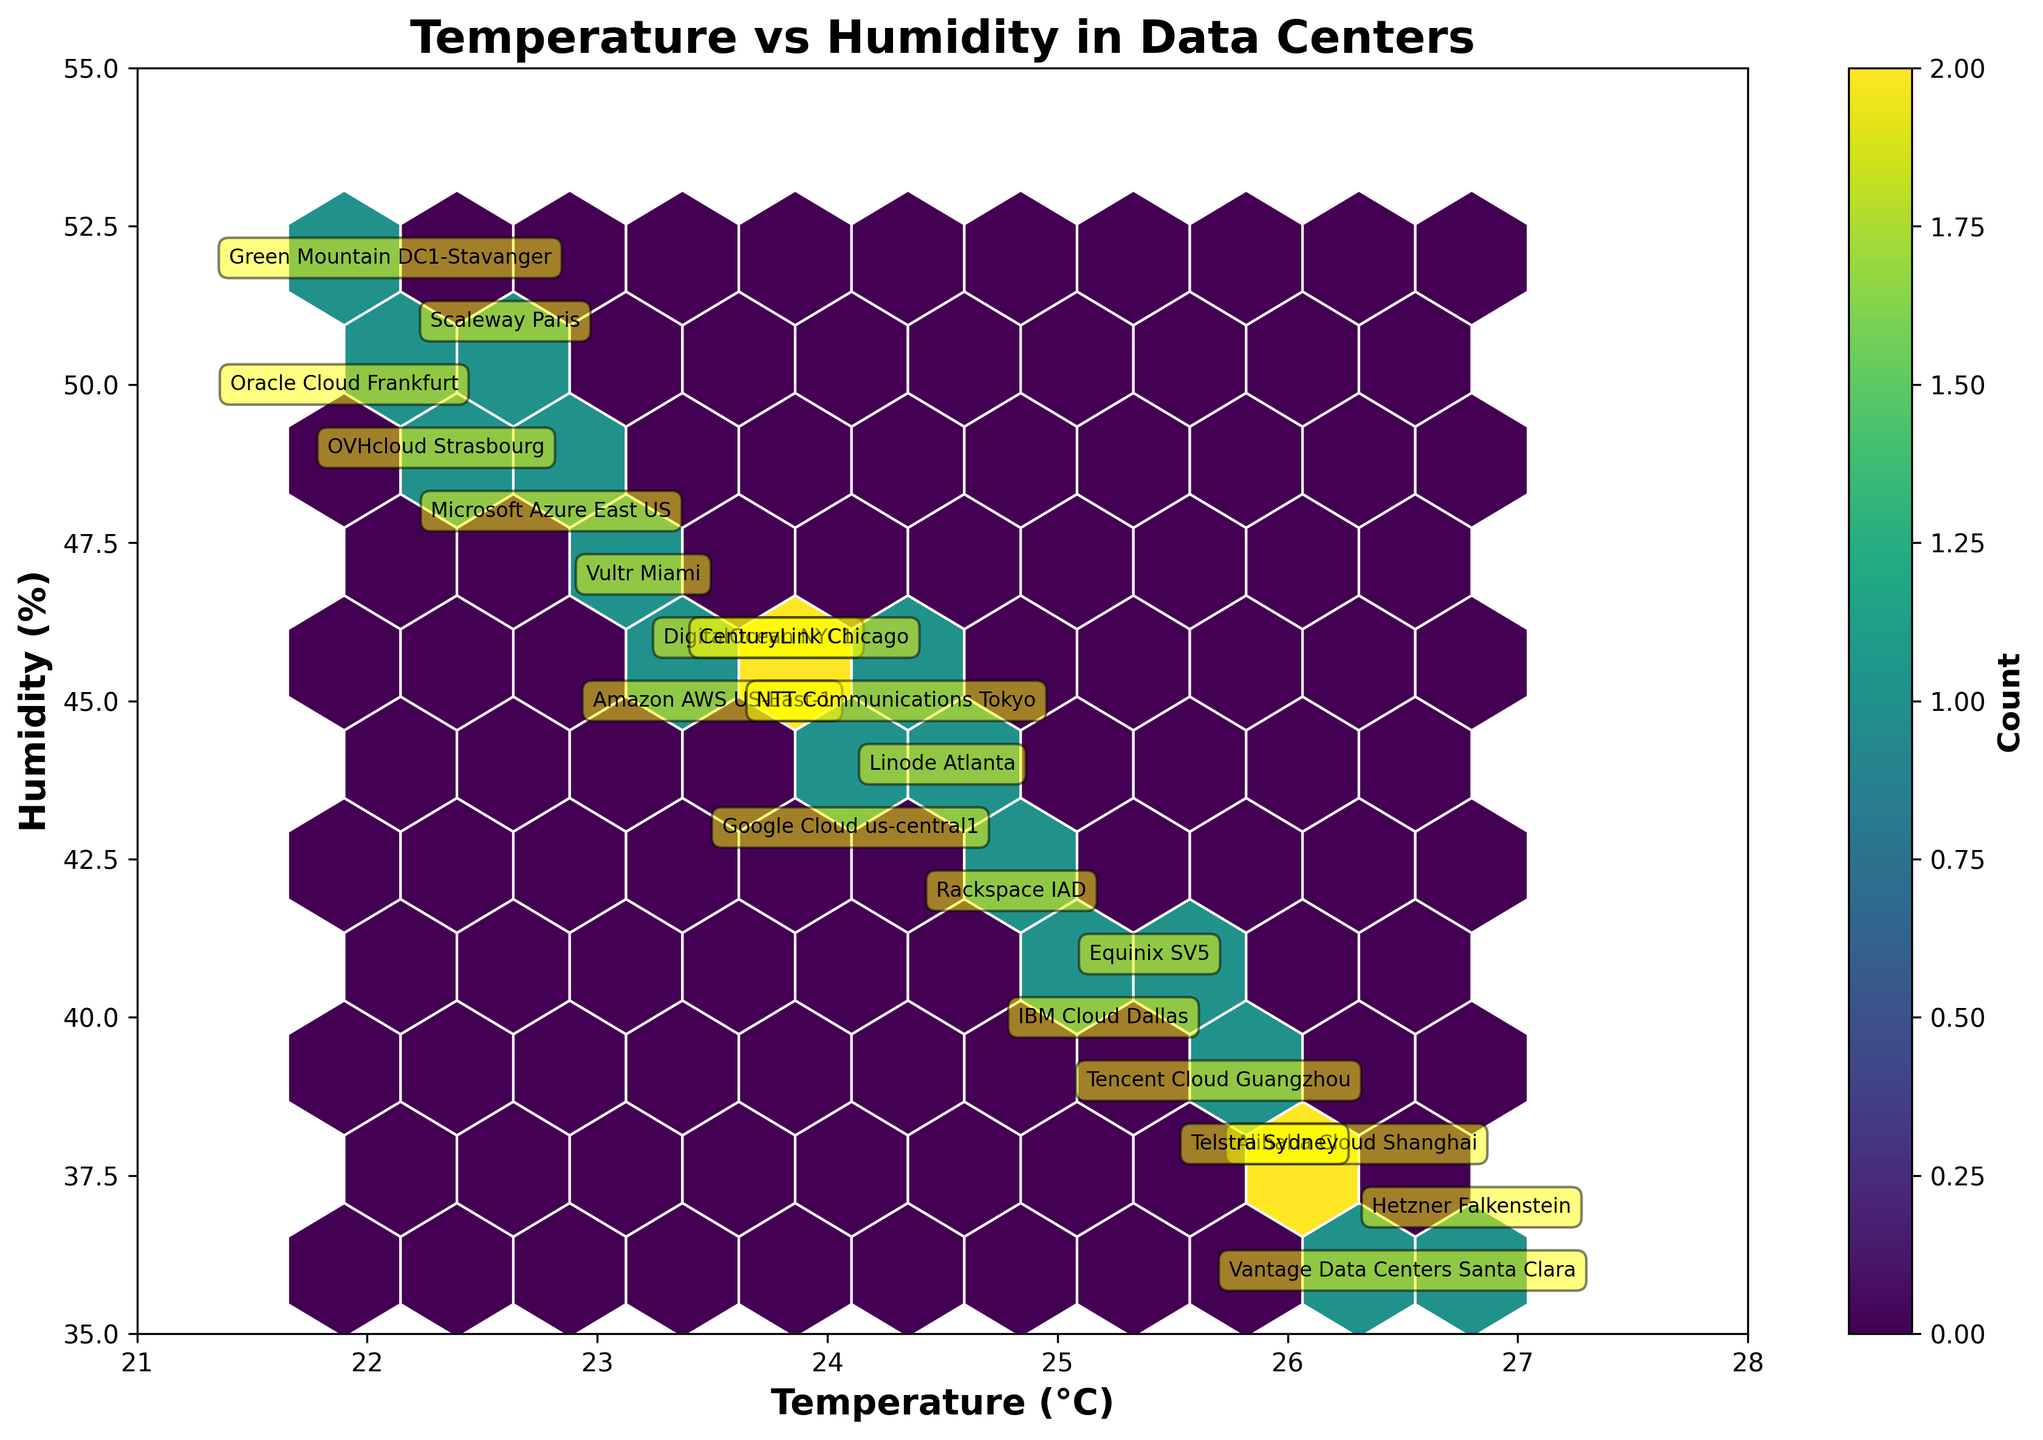What's the title of the plot? The title is always prominently displayed at the top of the plot. In this case, it reads "Temperature vs Humidity in Data Centers."
Answer: Temperature vs Humidity in Data Centers What are the labels for the x-axis and y-axis? The x-axis label and y-axis label provide context for the data represented in the plot. In this figure, the x-axis is labeled "Temperature (°C)" and the y-axis is labeled "Humidity (%)."
Answer: Temperature (°C) and Humidity (%) How many data points are displayed in the plot? Each data center is a unique data point on the plot. From the data provided, there are a total of 20 data centers, so there are 20 data points.
Answer: 20 Which data center has the highest temperature? By observing the labels and locating the data point with the highest x-axis value, we can see that "Hetzner Falkenstein" has the highest temperature reading of 26.8°C.
Answer: Hetzner Falkenstein Which data center experiences the highest humidity level? By examining the labels and finding the data point with the highest y-axis value, "Green Mountain DC1-Stavanger" has the highest humidity at 52%.
Answer: Green Mountain DC1-Stavanger What is the range of the x-axis and y-axis? The x-axis represents the temperature range from 21°C to 28°C, and the y-axis represents the humidity range from 35% to 55%, as set by the plot's axis limits.
Answer: 21°C to 28°C (Temperature) and 35% to 55% (Humidity) Which data center has the lowest humidity with a temperature above 25°C? To find the answer, we look for data points where the temperature is above 25°C and compare their humidity levels. "Hetzner Falkenstein" has the lowest humidity (37%) among data points with temperature above 25°C.
Answer: Hetzner Falkenstein Which two data centers have the closest temperature and humidity levels? To determine this, we would need to visually compare the proximity of data points with respect to both the x-axis (temperature) and y-axis (humidity). "CenturyLink Chicago" and "DigitalOcean NYC1" are close in both temperature (23.9°C and 23.7°C) and humidity (46% and 46%).
Answer: CenturyLink Chicago and DigitalOcean NYC1 What's the general trend you can infer from the plot between temperature and humidity levels in the data centers? A general trend can be inferred by looking at the overall distribution and clustering of the data points. The plot suggests a slight inverse relationship where higher temperatures tend to be associated with lower humidity levels.
Answer: Inverse relationship between temperature and humidity 